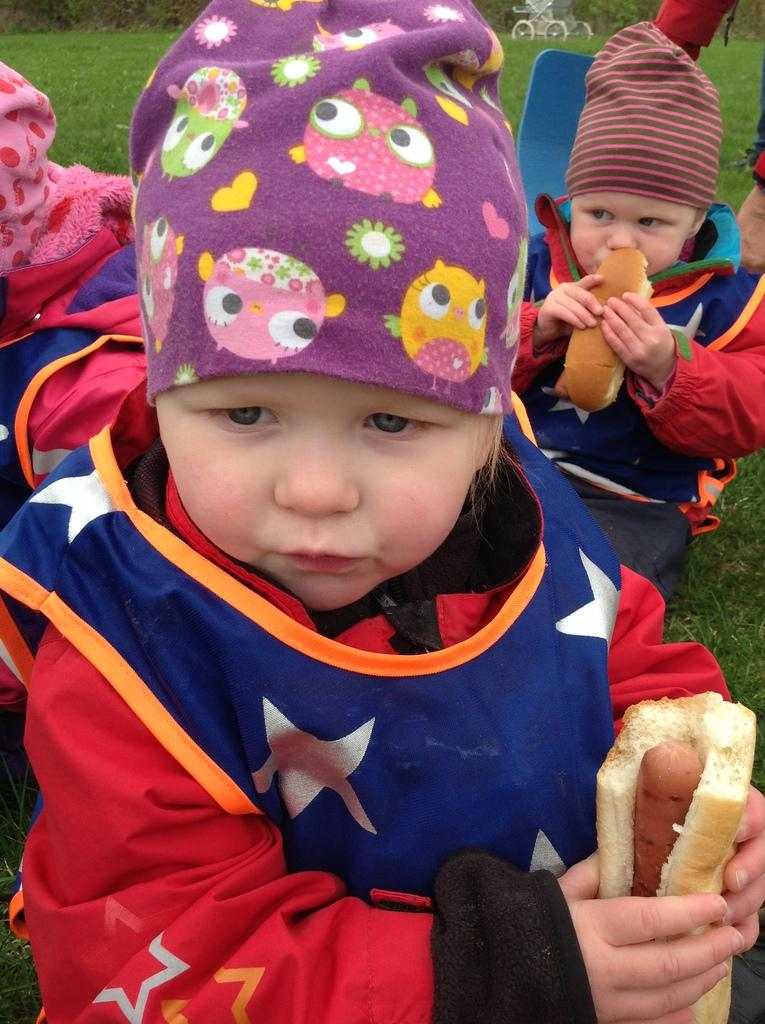Who is present in the image? There are children in the image. What are the children doing in the image? The children appear to be eating. What can be seen in the background of the image? There is grassland visible in the background of the image. How many frames are present in the image? There is no reference to frames in the image, so it is not possible to answer that question. 